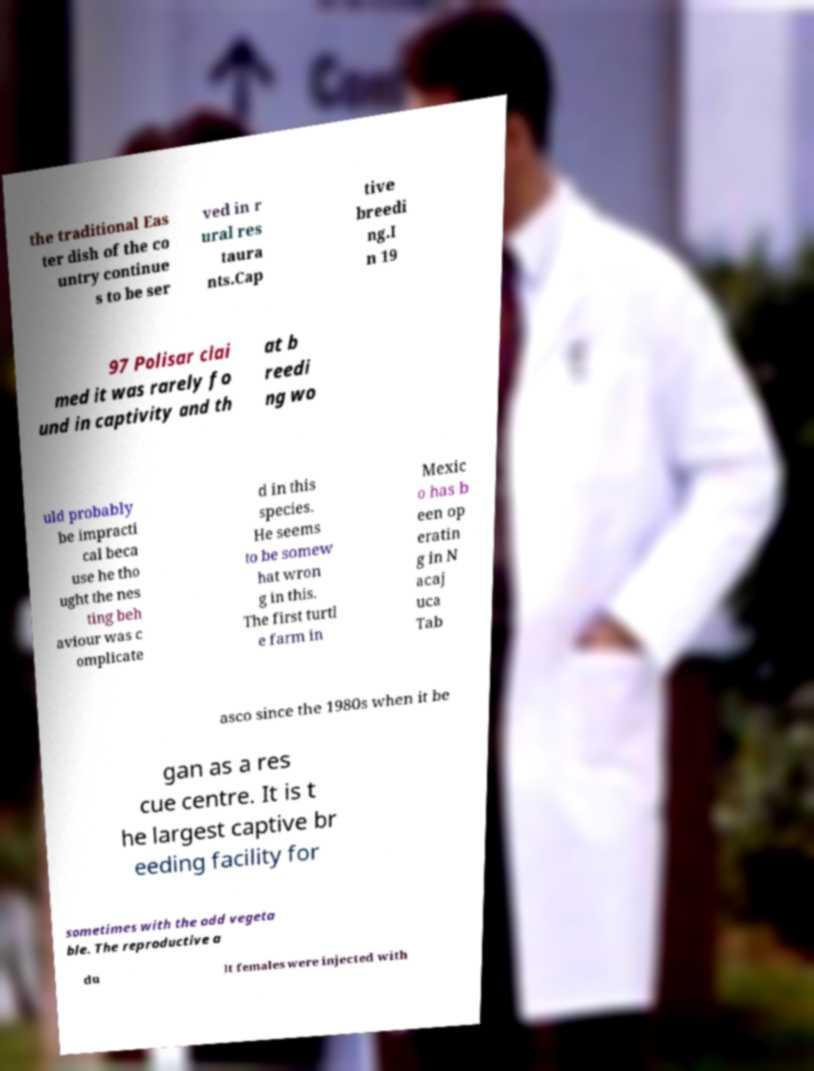Please read and relay the text visible in this image. What does it say? the traditional Eas ter dish of the co untry continue s to be ser ved in r ural res taura nts.Cap tive breedi ng.I n 19 97 Polisar clai med it was rarely fo und in captivity and th at b reedi ng wo uld probably be impracti cal beca use he tho ught the nes ting beh aviour was c omplicate d in this species. He seems to be somew hat wron g in this. The first turtl e farm in Mexic o has b een op eratin g in N acaj uca Tab asco since the 1980s when it be gan as a res cue centre. It is t he largest captive br eeding facility for sometimes with the odd vegeta ble. The reproductive a du lt females were injected with 